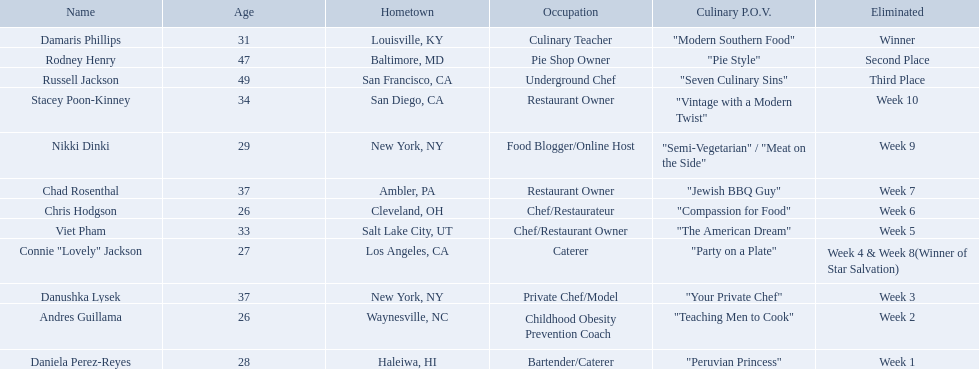Which food network star contestants are in their 20s? Nikki Dinki, Chris Hodgson, Connie "Lovely" Jackson, Andres Guillama, Daniela Perez-Reyes. Of these contestants, which one is the same age as chris hodgson? Andres Guillama. Can you parse all the data within this table? {'header': ['Name', 'Age', 'Hometown', 'Occupation', 'Culinary P.O.V.', 'Eliminated'], 'rows': [['Damaris Phillips', '31', 'Louisville, KY', 'Culinary Teacher', '"Modern Southern Food"', 'Winner'], ['Rodney Henry', '47', 'Baltimore, MD', 'Pie Shop Owner', '"Pie Style"', 'Second Place'], ['Russell Jackson', '49', 'San Francisco, CA', 'Underground Chef', '"Seven Culinary Sins"', 'Third Place'], ['Stacey Poon-Kinney', '34', 'San Diego, CA', 'Restaurant Owner', '"Vintage with a Modern Twist"', 'Week 10'], ['Nikki Dinki', '29', 'New York, NY', 'Food Blogger/Online Host', '"Semi-Vegetarian" / "Meat on the Side"', 'Week 9'], ['Chad Rosenthal', '37', 'Ambler, PA', 'Restaurant Owner', '"Jewish BBQ Guy"', 'Week 7'], ['Chris Hodgson', '26', 'Cleveland, OH', 'Chef/Restaurateur', '"Compassion for Food"', 'Week 6'], ['Viet Pham', '33', 'Salt Lake City, UT', 'Chef/Restaurant Owner', '"The American Dream"', 'Week 5'], ['Connie "Lovely" Jackson', '27', 'Los Angeles, CA', 'Caterer', '"Party on a Plate"', 'Week 4 & Week 8(Winner of Star Salvation)'], ['Danushka Lysek', '37', 'New York, NY', 'Private Chef/Model', '"Your Private Chef"', 'Week 3'], ['Andres Guillama', '26', 'Waynesville, NC', 'Childhood Obesity Prevention Coach', '"Teaching Men to Cook"', 'Week 2'], ['Daniela Perez-Reyes', '28', 'Haleiwa, HI', 'Bartender/Caterer', '"Peruvian Princess"', 'Week 1']]} Who where the people in the food network? Damaris Phillips, Rodney Henry, Russell Jackson, Stacey Poon-Kinney, Nikki Dinki, Chad Rosenthal, Chris Hodgson, Viet Pham, Connie "Lovely" Jackson, Danushka Lysek, Andres Guillama, Daniela Perez-Reyes. When was nikki dinki eliminated? Week 9. When was viet pham eliminated? Week 5. Which of these two is earlier? Week 5. Who was eliminated in this week? Viet Pham. Who are the  food network stars? Damaris Phillips, Rodney Henry, Russell Jackson, Stacey Poon-Kinney, Nikki Dinki, Chad Rosenthal, Chris Hodgson, Viet Pham, Connie "Lovely" Jackson, Danushka Lysek, Andres Guillama, Daniela Perez-Reyes. When did nikki dinki get eliminated? Week 9. When did viet pham get eliminated? Week 5. Which week came first? Week 5. Who was it that was eliminated week 5? Viet Pham. Who are all of the contestants? Damaris Phillips, Rodney Henry, Russell Jackson, Stacey Poon-Kinney, Nikki Dinki, Chad Rosenthal, Chris Hodgson, Viet Pham, Connie "Lovely" Jackson, Danushka Lysek, Andres Guillama, Daniela Perez-Reyes. Which culinary p.o.v. is longer than vintage with a modern twist? "Semi-Vegetarian" / "Meat on the Side". Which contestant's p.o.v. is semi-vegetarian/meat on the side? Nikki Dinki. Who are the enrolled food network star contestants? Damaris Phillips, Rodney Henry, Russell Jackson, Stacey Poon-Kinney, Nikki Dinki, Chad Rosenthal, Chris Hodgson, Viet Pham, Connie "Lovely" Jackson, Danushka Lysek, Andres Guillama, Daniela Perez-Reyes. Of those, who had the most extended p.o.v title? Nikki Dinki. Who are the food network celebrities? Damaris Phillips, Rodney Henry, Russell Jackson, Stacey Poon-Kinney, Nikki Dinki, Chad Rosenthal, Chris Hodgson, Viet Pham, Connie "Lovely" Jackson, Danushka Lysek, Andres Guillama, Daniela Perez-Reyes. When did nikki dinki get ousted? Week 9. When did viet pham get removed? Week 5. Which week was earlier? Week 5. Who was the individual eliminated during week 5? Viet Pham. Who are all the competitors? Damaris Phillips, Rodney Henry, Russell Jackson, Stacey Poon-Kinney, Nikki Dinki, Chad Rosenthal, Chris Hodgson, Viet Pham, Connie "Lovely" Jackson, Danushka Lysek, Andres Guillama, Daniela Perez-Reyes. What is each individual's culinary standpoint? "Modern Southern Food", "Pie Style", "Seven Culinary Sins", "Vintage with a Modern Twist", "Semi-Vegetarian" / "Meat on the Side", "Jewish BBQ Guy", "Compassion for Food", "The American Dream", "Party on a Plate", "Your Private Chef", "Teaching Men to Cook", "Peruvian Princess". And which person's standpoint is the lengthiest? Nikki Dinki. Can you name the competitors? Damaris Phillips, 31, Rodney Henry, 47, Russell Jackson, 49, Stacey Poon-Kinney, 34, Nikki Dinki, 29, Chad Rosenthal, 37, Chris Hodgson, 26, Viet Pham, 33, Connie "Lovely" Jackson, 27, Danushka Lysek, 37, Andres Guillama, 26, Daniela Perez-Reyes, 28. How many years old is chris hodgson? 26. Does any other contestant share his age? Andres Guillama. Apart from the champion, runner-up, and third-place finisher, which participants were eliminated? Stacey Poon-Kinney, Nikki Dinki, Chad Rosenthal, Chris Hodgson, Viet Pham, Connie "Lovely" Jackson, Danushka Lysek, Andres Guillama, Daniela Perez-Reyes. Among these contestants, who were the final five to be eliminated before the top three were revealed? Stacey Poon-Kinney, Nikki Dinki, Chad Rosenthal, Chris Hodgson, Viet Pham. Within these five contestants, who was eliminated first, nikki dinki or viet pham? Viet Pham. Who were the individuals involved in the food network? Damaris Phillips, Rodney Henry, Russell Jackson, Stacey Poon-Kinney, Nikki Dinki, Chad Rosenthal, Chris Hodgson, Viet Pham, Connie "Lovely" Jackson, Danushka Lysek, Andres Guillama, Daniela Perez-Reyes. When was nikki dinki eliminated? Week 9. When was viet pham eliminated? Week 5. Which of these two occurred first? Week 5. Who was eliminated this week? Viet Pham. Who participated in the food network? Damaris Phillips, Rodney Henry, Russell Jackson, Stacey Poon-Kinney, Nikki Dinki, Chad Rosenthal, Chris Hodgson, Viet Pham, Connie "Lovely" Jackson, Danushka Lysek, Andres Guillama, Daniela Perez-Reyes. When did nikki dinki get eliminated? Week 9. When did viet pham get eliminated? Week 5. Which of these two events happened earlier? Week 5. Who got eliminated this week? Viet Pham. Who are the celebrities on the food network? Damaris Phillips, Rodney Henry, Russell Jackson, Stacey Poon-Kinney, Nikki Dinki, Chad Rosenthal, Chris Hodgson, Viet Pham, Connie "Lovely" Jackson, Danushka Lysek, Andres Guillama, Daniela Perez-Reyes. At what point was nikki dinki removed from the competition? Week 9. When was viet pham's elimination? Week 5. Which elimination took place first? Week 5. Who was the participant that left the competition in week 5? Viet Pham. Can you provide a list of all the contestants? Damaris Phillips, Rodney Henry, Russell Jackson, Stacey Poon-Kinney, Nikki Dinki, Chad Rosenthal, Chris Hodgson, Viet Pham, Connie "Lovely" Jackson, Danushka Lysek, Andres Guillama, Daniela Perez-Reyes. Which participant's culinary perspective is more extended than the combination of vintage and modern elements? "Semi-Vegetarian" / "Meat on the Side". Who among the contestants has a semi-vegetarian or meat-on-the-side approach? Nikki Dinki. Can you list all the competitors? Damaris Phillips, Rodney Henry, Russell Jackson, Stacey Poon-Kinney, Nikki Dinki, Chad Rosenthal, Chris Hodgson, Viet Pham, Connie "Lovely" Jackson, Danushka Lysek, Andres Guillama, Daniela Perez-Reyes. What is the unique culinary approach of each player? "Modern Southern Food", "Pie Style", "Seven Culinary Sins", "Vintage with a Modern Twist", "Semi-Vegetarian" / "Meat on the Side", "Jewish BBQ Guy", "Compassion for Food", "The American Dream", "Party on a Plate", "Your Private Chef", "Teaching Men to Cook", "Peruvian Princess". And who has the lengthiest approach? Nikki Dinki. 